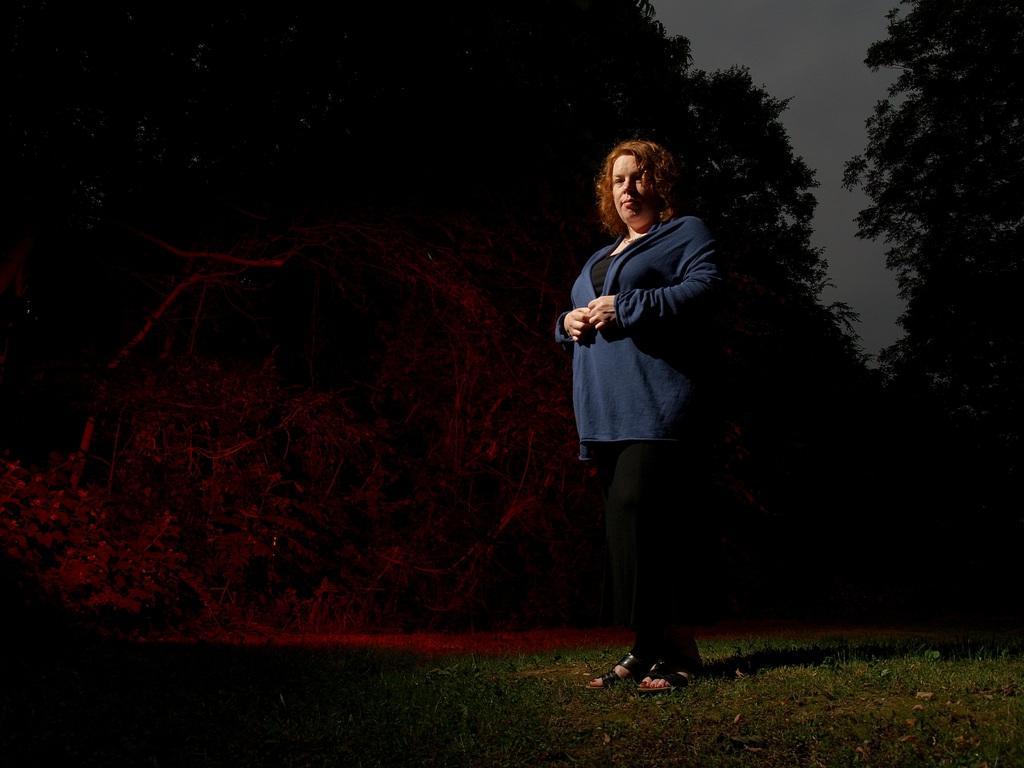In one or two sentences, can you explain what this image depicts? In the center of the image we can see a lady is standing and wearing a dress. In the background of the image we can see the trees. At the bottom of the image we can see the ground. At the top of the image we can see the sky. 